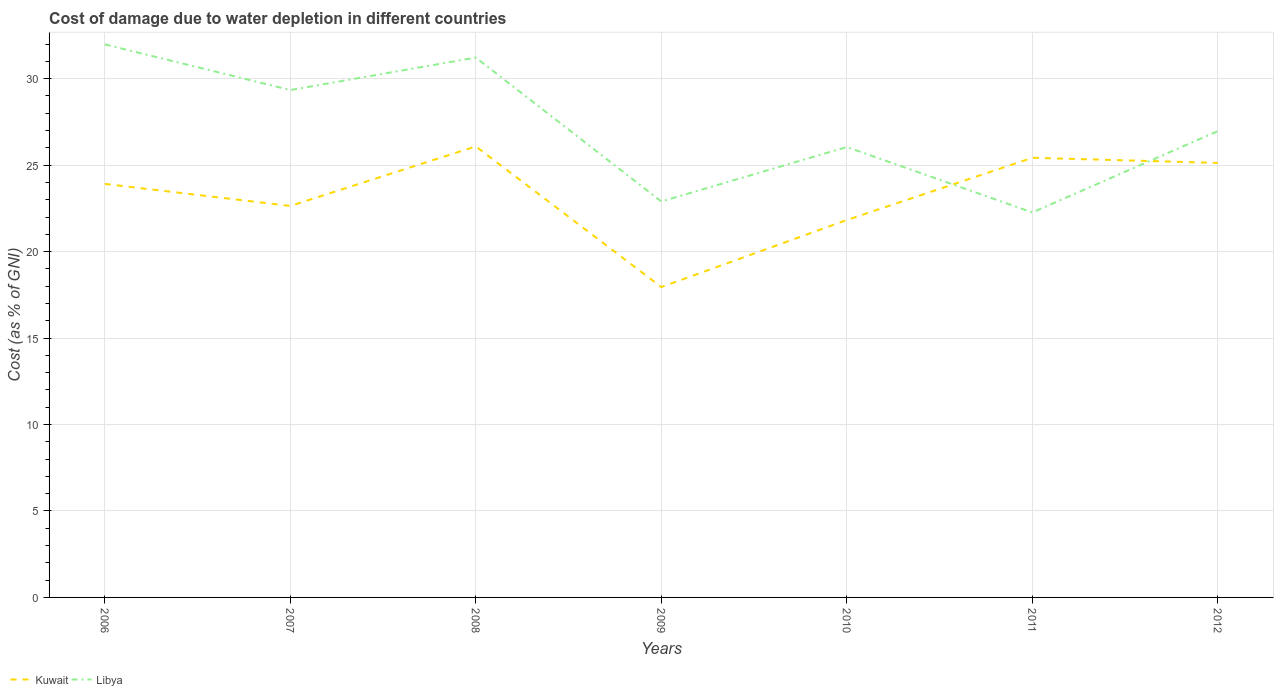How many different coloured lines are there?
Ensure brevity in your answer.  2. Does the line corresponding to Libya intersect with the line corresponding to Kuwait?
Offer a terse response. Yes. Is the number of lines equal to the number of legend labels?
Provide a succinct answer. Yes. Across all years, what is the maximum cost of damage caused due to water depletion in Kuwait?
Provide a short and direct response. 17.95. In which year was the cost of damage caused due to water depletion in Libya maximum?
Your response must be concise. 2011. What is the total cost of damage caused due to water depletion in Libya in the graph?
Offer a very short reply. -4.07. What is the difference between the highest and the second highest cost of damage caused due to water depletion in Kuwait?
Make the answer very short. 8.14. What is the difference between the highest and the lowest cost of damage caused due to water depletion in Libya?
Provide a short and direct response. 3. Is the cost of damage caused due to water depletion in Kuwait strictly greater than the cost of damage caused due to water depletion in Libya over the years?
Keep it short and to the point. No. How many lines are there?
Your response must be concise. 2. What is the difference between two consecutive major ticks on the Y-axis?
Provide a succinct answer. 5. Does the graph contain grids?
Your answer should be very brief. Yes. What is the title of the graph?
Your response must be concise. Cost of damage due to water depletion in different countries. What is the label or title of the X-axis?
Offer a very short reply. Years. What is the label or title of the Y-axis?
Your answer should be compact. Cost (as % of GNI). What is the Cost (as % of GNI) of Kuwait in 2006?
Your answer should be compact. 23.91. What is the Cost (as % of GNI) in Libya in 2006?
Offer a very short reply. 31.98. What is the Cost (as % of GNI) in Kuwait in 2007?
Your answer should be very brief. 22.64. What is the Cost (as % of GNI) of Libya in 2007?
Offer a terse response. 29.34. What is the Cost (as % of GNI) in Kuwait in 2008?
Offer a terse response. 26.08. What is the Cost (as % of GNI) of Libya in 2008?
Keep it short and to the point. 31.22. What is the Cost (as % of GNI) of Kuwait in 2009?
Provide a short and direct response. 17.95. What is the Cost (as % of GNI) of Libya in 2009?
Your answer should be very brief. 22.9. What is the Cost (as % of GNI) in Kuwait in 2010?
Provide a succinct answer. 21.83. What is the Cost (as % of GNI) of Libya in 2010?
Your answer should be compact. 26.05. What is the Cost (as % of GNI) in Kuwait in 2011?
Your response must be concise. 25.43. What is the Cost (as % of GNI) of Libya in 2011?
Make the answer very short. 22.26. What is the Cost (as % of GNI) in Kuwait in 2012?
Keep it short and to the point. 25.13. What is the Cost (as % of GNI) in Libya in 2012?
Your answer should be compact. 26.97. Across all years, what is the maximum Cost (as % of GNI) in Kuwait?
Provide a succinct answer. 26.08. Across all years, what is the maximum Cost (as % of GNI) of Libya?
Make the answer very short. 31.98. Across all years, what is the minimum Cost (as % of GNI) in Kuwait?
Provide a short and direct response. 17.95. Across all years, what is the minimum Cost (as % of GNI) of Libya?
Your answer should be compact. 22.26. What is the total Cost (as % of GNI) in Kuwait in the graph?
Your response must be concise. 162.97. What is the total Cost (as % of GNI) of Libya in the graph?
Your answer should be very brief. 190.73. What is the difference between the Cost (as % of GNI) of Kuwait in 2006 and that in 2007?
Your answer should be very brief. 1.28. What is the difference between the Cost (as % of GNI) in Libya in 2006 and that in 2007?
Provide a succinct answer. 2.64. What is the difference between the Cost (as % of GNI) in Kuwait in 2006 and that in 2008?
Your answer should be compact. -2.17. What is the difference between the Cost (as % of GNI) in Libya in 2006 and that in 2008?
Ensure brevity in your answer.  0.76. What is the difference between the Cost (as % of GNI) in Kuwait in 2006 and that in 2009?
Your answer should be compact. 5.97. What is the difference between the Cost (as % of GNI) in Libya in 2006 and that in 2009?
Your answer should be compact. 9.09. What is the difference between the Cost (as % of GNI) in Kuwait in 2006 and that in 2010?
Offer a very short reply. 2.09. What is the difference between the Cost (as % of GNI) in Libya in 2006 and that in 2010?
Your answer should be compact. 5.94. What is the difference between the Cost (as % of GNI) in Kuwait in 2006 and that in 2011?
Offer a terse response. -1.51. What is the difference between the Cost (as % of GNI) in Libya in 2006 and that in 2011?
Provide a short and direct response. 9.72. What is the difference between the Cost (as % of GNI) of Kuwait in 2006 and that in 2012?
Keep it short and to the point. -1.21. What is the difference between the Cost (as % of GNI) of Libya in 2006 and that in 2012?
Offer a terse response. 5.01. What is the difference between the Cost (as % of GNI) in Kuwait in 2007 and that in 2008?
Provide a succinct answer. -3.44. What is the difference between the Cost (as % of GNI) in Libya in 2007 and that in 2008?
Provide a succinct answer. -1.88. What is the difference between the Cost (as % of GNI) in Kuwait in 2007 and that in 2009?
Keep it short and to the point. 4.69. What is the difference between the Cost (as % of GNI) in Libya in 2007 and that in 2009?
Provide a succinct answer. 6.44. What is the difference between the Cost (as % of GNI) of Kuwait in 2007 and that in 2010?
Your answer should be compact. 0.81. What is the difference between the Cost (as % of GNI) of Libya in 2007 and that in 2010?
Keep it short and to the point. 3.3. What is the difference between the Cost (as % of GNI) in Kuwait in 2007 and that in 2011?
Your response must be concise. -2.79. What is the difference between the Cost (as % of GNI) of Libya in 2007 and that in 2011?
Ensure brevity in your answer.  7.08. What is the difference between the Cost (as % of GNI) of Kuwait in 2007 and that in 2012?
Your answer should be very brief. -2.49. What is the difference between the Cost (as % of GNI) in Libya in 2007 and that in 2012?
Make the answer very short. 2.37. What is the difference between the Cost (as % of GNI) in Kuwait in 2008 and that in 2009?
Make the answer very short. 8.14. What is the difference between the Cost (as % of GNI) in Libya in 2008 and that in 2009?
Your answer should be very brief. 8.32. What is the difference between the Cost (as % of GNI) in Kuwait in 2008 and that in 2010?
Offer a very short reply. 4.26. What is the difference between the Cost (as % of GNI) of Libya in 2008 and that in 2010?
Provide a succinct answer. 5.17. What is the difference between the Cost (as % of GNI) in Kuwait in 2008 and that in 2011?
Offer a terse response. 0.66. What is the difference between the Cost (as % of GNI) of Libya in 2008 and that in 2011?
Offer a terse response. 8.96. What is the difference between the Cost (as % of GNI) of Kuwait in 2008 and that in 2012?
Give a very brief answer. 0.96. What is the difference between the Cost (as % of GNI) of Libya in 2008 and that in 2012?
Make the answer very short. 4.25. What is the difference between the Cost (as % of GNI) in Kuwait in 2009 and that in 2010?
Ensure brevity in your answer.  -3.88. What is the difference between the Cost (as % of GNI) of Libya in 2009 and that in 2010?
Make the answer very short. -3.15. What is the difference between the Cost (as % of GNI) in Kuwait in 2009 and that in 2011?
Provide a succinct answer. -7.48. What is the difference between the Cost (as % of GNI) of Libya in 2009 and that in 2011?
Offer a terse response. 0.63. What is the difference between the Cost (as % of GNI) in Kuwait in 2009 and that in 2012?
Offer a very short reply. -7.18. What is the difference between the Cost (as % of GNI) in Libya in 2009 and that in 2012?
Your answer should be compact. -4.07. What is the difference between the Cost (as % of GNI) of Kuwait in 2010 and that in 2011?
Your answer should be very brief. -3.6. What is the difference between the Cost (as % of GNI) in Libya in 2010 and that in 2011?
Your answer should be compact. 3.78. What is the difference between the Cost (as % of GNI) of Kuwait in 2010 and that in 2012?
Ensure brevity in your answer.  -3.3. What is the difference between the Cost (as % of GNI) in Libya in 2010 and that in 2012?
Your answer should be compact. -0.92. What is the difference between the Cost (as % of GNI) in Kuwait in 2011 and that in 2012?
Keep it short and to the point. 0.3. What is the difference between the Cost (as % of GNI) of Libya in 2011 and that in 2012?
Offer a very short reply. -4.71. What is the difference between the Cost (as % of GNI) of Kuwait in 2006 and the Cost (as % of GNI) of Libya in 2007?
Your answer should be compact. -5.43. What is the difference between the Cost (as % of GNI) in Kuwait in 2006 and the Cost (as % of GNI) in Libya in 2008?
Your answer should be compact. -7.31. What is the difference between the Cost (as % of GNI) of Kuwait in 2006 and the Cost (as % of GNI) of Libya in 2009?
Your answer should be very brief. 1.02. What is the difference between the Cost (as % of GNI) in Kuwait in 2006 and the Cost (as % of GNI) in Libya in 2010?
Offer a very short reply. -2.13. What is the difference between the Cost (as % of GNI) of Kuwait in 2006 and the Cost (as % of GNI) of Libya in 2011?
Offer a terse response. 1.65. What is the difference between the Cost (as % of GNI) in Kuwait in 2006 and the Cost (as % of GNI) in Libya in 2012?
Keep it short and to the point. -3.05. What is the difference between the Cost (as % of GNI) in Kuwait in 2007 and the Cost (as % of GNI) in Libya in 2008?
Provide a short and direct response. -8.58. What is the difference between the Cost (as % of GNI) in Kuwait in 2007 and the Cost (as % of GNI) in Libya in 2009?
Your answer should be compact. -0.26. What is the difference between the Cost (as % of GNI) of Kuwait in 2007 and the Cost (as % of GNI) of Libya in 2010?
Your response must be concise. -3.41. What is the difference between the Cost (as % of GNI) of Kuwait in 2007 and the Cost (as % of GNI) of Libya in 2012?
Your answer should be compact. -4.33. What is the difference between the Cost (as % of GNI) in Kuwait in 2008 and the Cost (as % of GNI) in Libya in 2009?
Your answer should be compact. 3.19. What is the difference between the Cost (as % of GNI) of Kuwait in 2008 and the Cost (as % of GNI) of Libya in 2010?
Keep it short and to the point. 0.04. What is the difference between the Cost (as % of GNI) in Kuwait in 2008 and the Cost (as % of GNI) in Libya in 2011?
Keep it short and to the point. 3.82. What is the difference between the Cost (as % of GNI) of Kuwait in 2008 and the Cost (as % of GNI) of Libya in 2012?
Your response must be concise. -0.89. What is the difference between the Cost (as % of GNI) of Kuwait in 2009 and the Cost (as % of GNI) of Libya in 2010?
Give a very brief answer. -8.1. What is the difference between the Cost (as % of GNI) of Kuwait in 2009 and the Cost (as % of GNI) of Libya in 2011?
Your answer should be compact. -4.32. What is the difference between the Cost (as % of GNI) in Kuwait in 2009 and the Cost (as % of GNI) in Libya in 2012?
Offer a very short reply. -9.02. What is the difference between the Cost (as % of GNI) of Kuwait in 2010 and the Cost (as % of GNI) of Libya in 2011?
Keep it short and to the point. -0.44. What is the difference between the Cost (as % of GNI) in Kuwait in 2010 and the Cost (as % of GNI) in Libya in 2012?
Your answer should be very brief. -5.14. What is the difference between the Cost (as % of GNI) of Kuwait in 2011 and the Cost (as % of GNI) of Libya in 2012?
Provide a succinct answer. -1.54. What is the average Cost (as % of GNI) in Kuwait per year?
Offer a very short reply. 23.28. What is the average Cost (as % of GNI) of Libya per year?
Give a very brief answer. 27.25. In the year 2006, what is the difference between the Cost (as % of GNI) of Kuwait and Cost (as % of GNI) of Libya?
Ensure brevity in your answer.  -8.07. In the year 2007, what is the difference between the Cost (as % of GNI) in Kuwait and Cost (as % of GNI) in Libya?
Your answer should be very brief. -6.7. In the year 2008, what is the difference between the Cost (as % of GNI) in Kuwait and Cost (as % of GNI) in Libya?
Ensure brevity in your answer.  -5.14. In the year 2009, what is the difference between the Cost (as % of GNI) in Kuwait and Cost (as % of GNI) in Libya?
Your response must be concise. -4.95. In the year 2010, what is the difference between the Cost (as % of GNI) in Kuwait and Cost (as % of GNI) in Libya?
Your answer should be very brief. -4.22. In the year 2011, what is the difference between the Cost (as % of GNI) of Kuwait and Cost (as % of GNI) of Libya?
Give a very brief answer. 3.16. In the year 2012, what is the difference between the Cost (as % of GNI) in Kuwait and Cost (as % of GNI) in Libya?
Make the answer very short. -1.84. What is the ratio of the Cost (as % of GNI) of Kuwait in 2006 to that in 2007?
Your answer should be very brief. 1.06. What is the ratio of the Cost (as % of GNI) in Libya in 2006 to that in 2007?
Your answer should be compact. 1.09. What is the ratio of the Cost (as % of GNI) in Kuwait in 2006 to that in 2008?
Offer a very short reply. 0.92. What is the ratio of the Cost (as % of GNI) of Libya in 2006 to that in 2008?
Keep it short and to the point. 1.02. What is the ratio of the Cost (as % of GNI) in Kuwait in 2006 to that in 2009?
Provide a short and direct response. 1.33. What is the ratio of the Cost (as % of GNI) in Libya in 2006 to that in 2009?
Make the answer very short. 1.4. What is the ratio of the Cost (as % of GNI) of Kuwait in 2006 to that in 2010?
Make the answer very short. 1.1. What is the ratio of the Cost (as % of GNI) in Libya in 2006 to that in 2010?
Your answer should be compact. 1.23. What is the ratio of the Cost (as % of GNI) of Kuwait in 2006 to that in 2011?
Provide a succinct answer. 0.94. What is the ratio of the Cost (as % of GNI) of Libya in 2006 to that in 2011?
Keep it short and to the point. 1.44. What is the ratio of the Cost (as % of GNI) of Kuwait in 2006 to that in 2012?
Keep it short and to the point. 0.95. What is the ratio of the Cost (as % of GNI) of Libya in 2006 to that in 2012?
Make the answer very short. 1.19. What is the ratio of the Cost (as % of GNI) of Kuwait in 2007 to that in 2008?
Keep it short and to the point. 0.87. What is the ratio of the Cost (as % of GNI) of Libya in 2007 to that in 2008?
Give a very brief answer. 0.94. What is the ratio of the Cost (as % of GNI) of Kuwait in 2007 to that in 2009?
Offer a terse response. 1.26. What is the ratio of the Cost (as % of GNI) of Libya in 2007 to that in 2009?
Provide a short and direct response. 1.28. What is the ratio of the Cost (as % of GNI) of Kuwait in 2007 to that in 2010?
Provide a short and direct response. 1.04. What is the ratio of the Cost (as % of GNI) of Libya in 2007 to that in 2010?
Make the answer very short. 1.13. What is the ratio of the Cost (as % of GNI) of Kuwait in 2007 to that in 2011?
Your answer should be very brief. 0.89. What is the ratio of the Cost (as % of GNI) of Libya in 2007 to that in 2011?
Provide a short and direct response. 1.32. What is the ratio of the Cost (as % of GNI) of Kuwait in 2007 to that in 2012?
Your response must be concise. 0.9. What is the ratio of the Cost (as % of GNI) in Libya in 2007 to that in 2012?
Offer a terse response. 1.09. What is the ratio of the Cost (as % of GNI) in Kuwait in 2008 to that in 2009?
Your response must be concise. 1.45. What is the ratio of the Cost (as % of GNI) in Libya in 2008 to that in 2009?
Make the answer very short. 1.36. What is the ratio of the Cost (as % of GNI) in Kuwait in 2008 to that in 2010?
Give a very brief answer. 1.2. What is the ratio of the Cost (as % of GNI) of Libya in 2008 to that in 2010?
Your answer should be very brief. 1.2. What is the ratio of the Cost (as % of GNI) of Kuwait in 2008 to that in 2011?
Offer a terse response. 1.03. What is the ratio of the Cost (as % of GNI) of Libya in 2008 to that in 2011?
Your answer should be very brief. 1.4. What is the ratio of the Cost (as % of GNI) of Kuwait in 2008 to that in 2012?
Ensure brevity in your answer.  1.04. What is the ratio of the Cost (as % of GNI) in Libya in 2008 to that in 2012?
Provide a succinct answer. 1.16. What is the ratio of the Cost (as % of GNI) of Kuwait in 2009 to that in 2010?
Your answer should be very brief. 0.82. What is the ratio of the Cost (as % of GNI) of Libya in 2009 to that in 2010?
Make the answer very short. 0.88. What is the ratio of the Cost (as % of GNI) in Kuwait in 2009 to that in 2011?
Ensure brevity in your answer.  0.71. What is the ratio of the Cost (as % of GNI) of Libya in 2009 to that in 2011?
Ensure brevity in your answer.  1.03. What is the ratio of the Cost (as % of GNI) of Kuwait in 2009 to that in 2012?
Offer a very short reply. 0.71. What is the ratio of the Cost (as % of GNI) of Libya in 2009 to that in 2012?
Keep it short and to the point. 0.85. What is the ratio of the Cost (as % of GNI) in Kuwait in 2010 to that in 2011?
Your answer should be very brief. 0.86. What is the ratio of the Cost (as % of GNI) in Libya in 2010 to that in 2011?
Keep it short and to the point. 1.17. What is the ratio of the Cost (as % of GNI) in Kuwait in 2010 to that in 2012?
Your answer should be very brief. 0.87. What is the ratio of the Cost (as % of GNI) in Libya in 2010 to that in 2012?
Offer a terse response. 0.97. What is the ratio of the Cost (as % of GNI) of Kuwait in 2011 to that in 2012?
Your response must be concise. 1.01. What is the ratio of the Cost (as % of GNI) in Libya in 2011 to that in 2012?
Your answer should be compact. 0.83. What is the difference between the highest and the second highest Cost (as % of GNI) of Kuwait?
Provide a succinct answer. 0.66. What is the difference between the highest and the second highest Cost (as % of GNI) of Libya?
Provide a short and direct response. 0.76. What is the difference between the highest and the lowest Cost (as % of GNI) in Kuwait?
Ensure brevity in your answer.  8.14. What is the difference between the highest and the lowest Cost (as % of GNI) of Libya?
Provide a succinct answer. 9.72. 